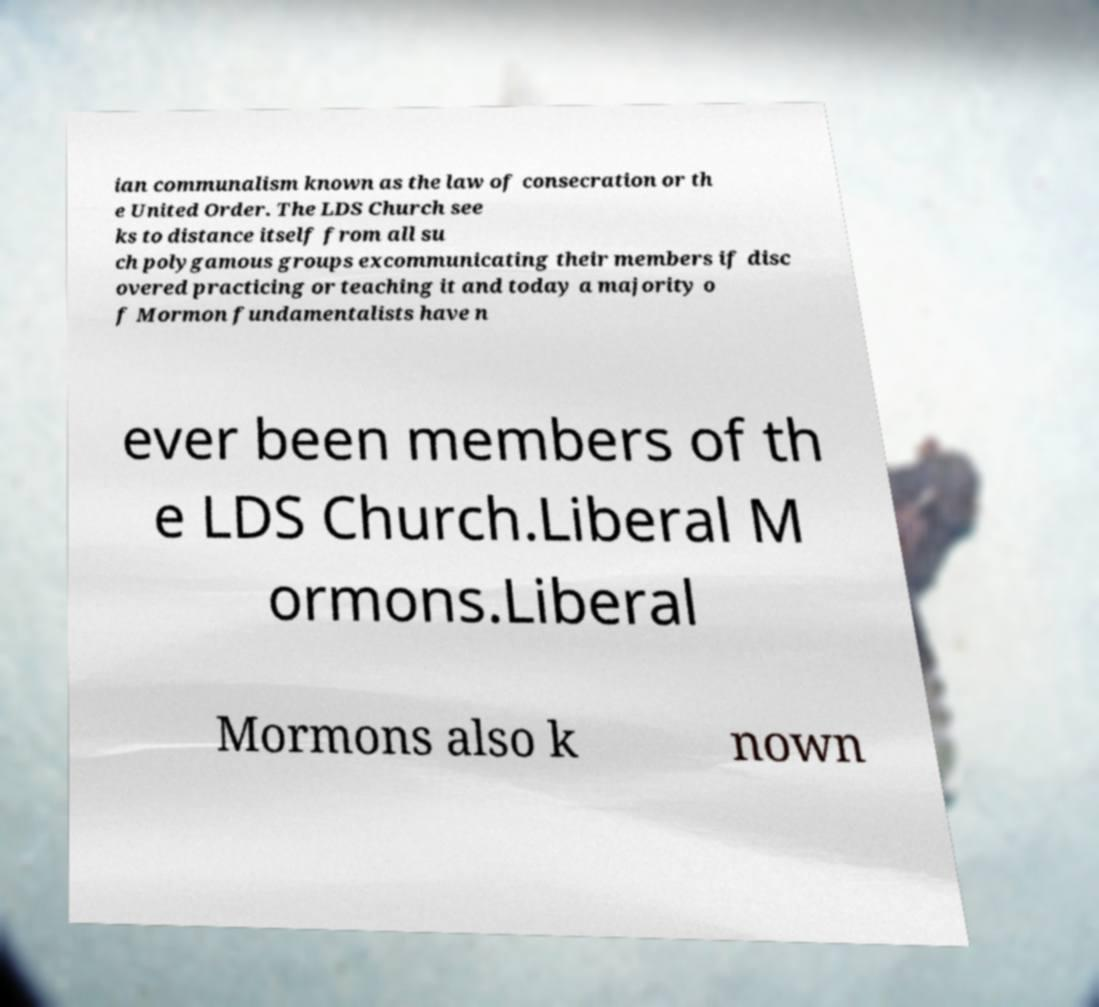There's text embedded in this image that I need extracted. Can you transcribe it verbatim? ian communalism known as the law of consecration or th e United Order. The LDS Church see ks to distance itself from all su ch polygamous groups excommunicating their members if disc overed practicing or teaching it and today a majority o f Mormon fundamentalists have n ever been members of th e LDS Church.Liberal M ormons.Liberal Mormons also k nown 